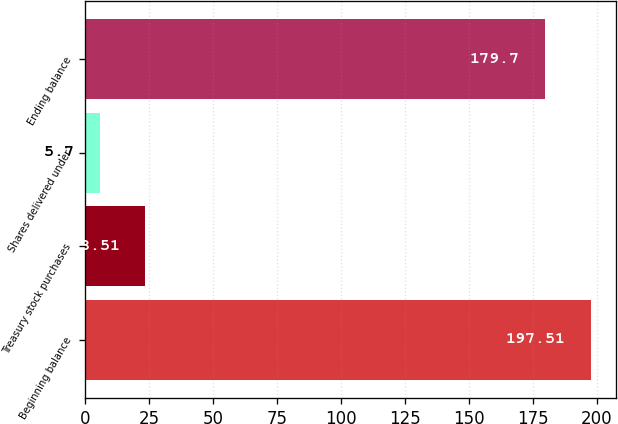<chart> <loc_0><loc_0><loc_500><loc_500><bar_chart><fcel>Beginning balance<fcel>Treasury stock purchases<fcel>Shares delivered under<fcel>Ending balance<nl><fcel>197.51<fcel>23.51<fcel>5.7<fcel>179.7<nl></chart> 